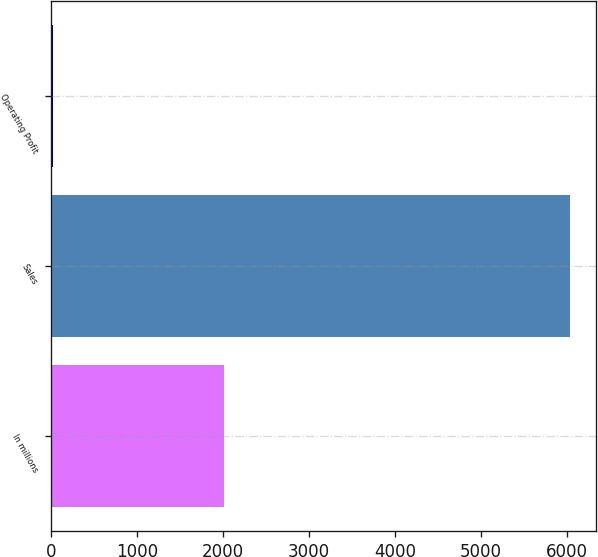Convert chart to OTSL. <chart><loc_0><loc_0><loc_500><loc_500><bar_chart><fcel>In millions<fcel>Sales<fcel>Operating Profit<nl><fcel>2012<fcel>6040<fcel>22<nl></chart> 